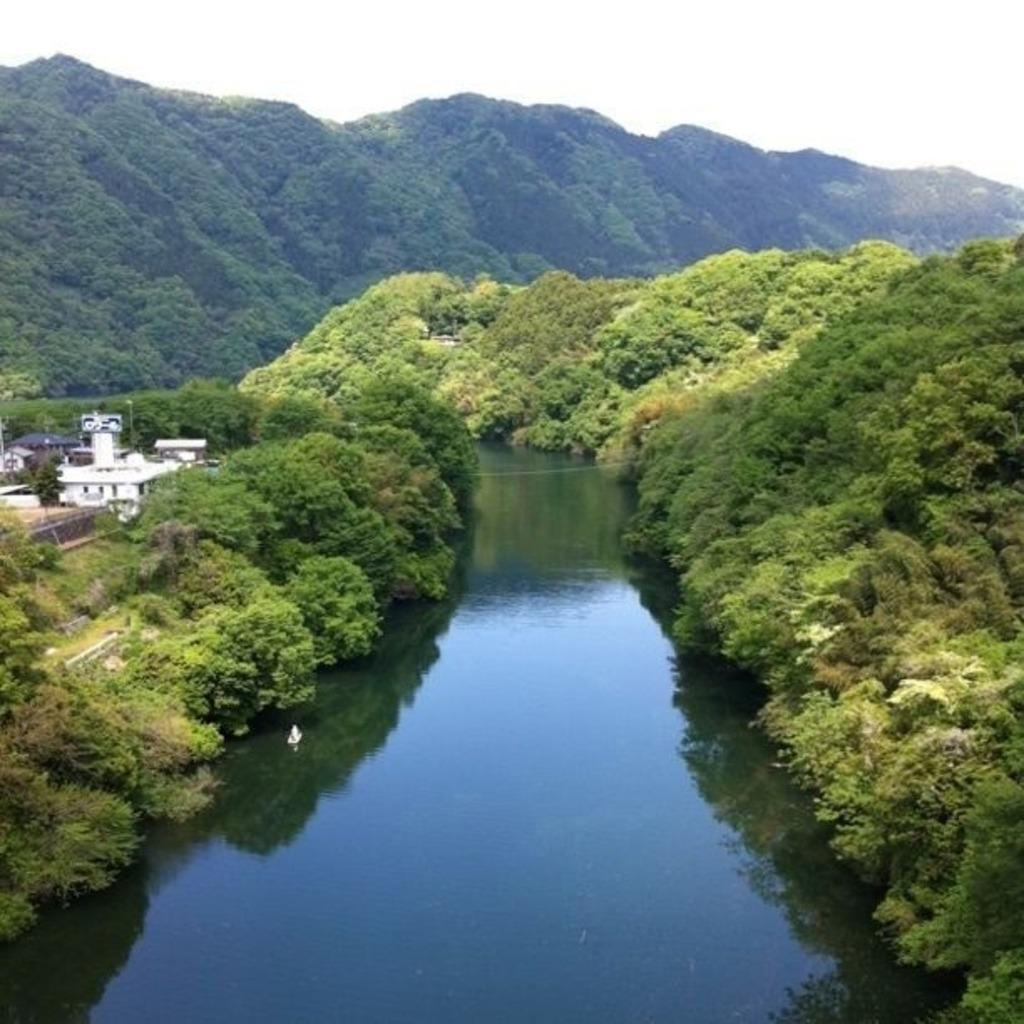What is the primary element present in the image? There is water in the image. What other natural elements can be seen in the image? There are plants and trees in the image. What type of human-made structures are visible in the image? There are homes in the image. What is visible at the top of the image? The sky is visible at the top of the image. How many chickens are present in the image? There are no chickens present in the image. What type of wheel can be seen attached to the homes in the image? There are no wheels visible in the image, and the homes do not have any wheels attached to them. 